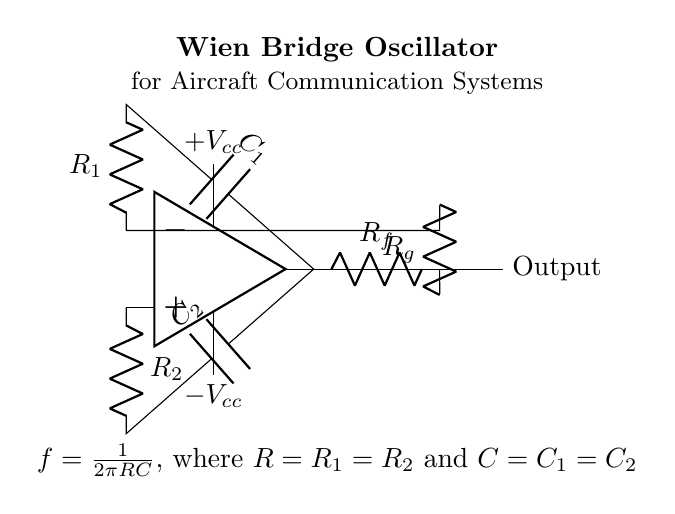What is the purpose of this circuit? The Wien bridge oscillator is used to generate audio tones, which are essential for communication systems in aircraft. This enables the transmission and reception of audio signals effectively.
Answer: Generating audio tones What components are used in this circuit? The circuit consists of operational amplifier, resistors (R1, R2, Rf, Rg), and capacitors (C1, C2). These components work together to create the oscillating signal.
Answer: Operational amplifier, resistors, capacitors What is the value of R1 and R2? Both R1 and R2 are equal in value and form part of the frequency determining network for the oscillator, as indicated in the frequency equation.
Answer: Equal values What type of oscillator is represented in the diagram? The circuit diagram represents a Wien bridge oscillator, which is a type of analog oscillator known for its simplicity and ability to generate sine waves.
Answer: Wien bridge oscillator How is the feedback implemented in the circuit? Feedback is provided by the resistors Rf and Rg connected from the output to the inverting input of the operational amplifier, configuring it as a negative feedback network that stabilizes oscillation.
Answer: Negative feedback What does the frequency equation for the oscillator indicate? The frequency equation states that the frequency of the oscillation is determined by the values of the resistors and capacitors, specifically that the frequency is inversely proportional to the product of RC, where both R and C are equal.
Answer: Frequency determined by RC 